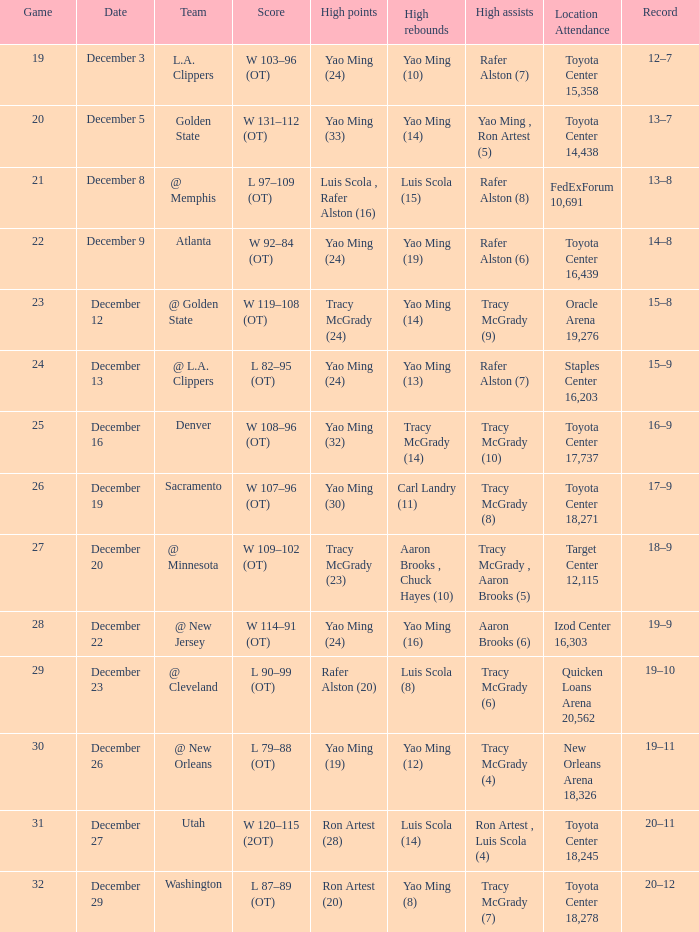When tracy mcgrady (8) is leading in assists what is the date? December 19. 